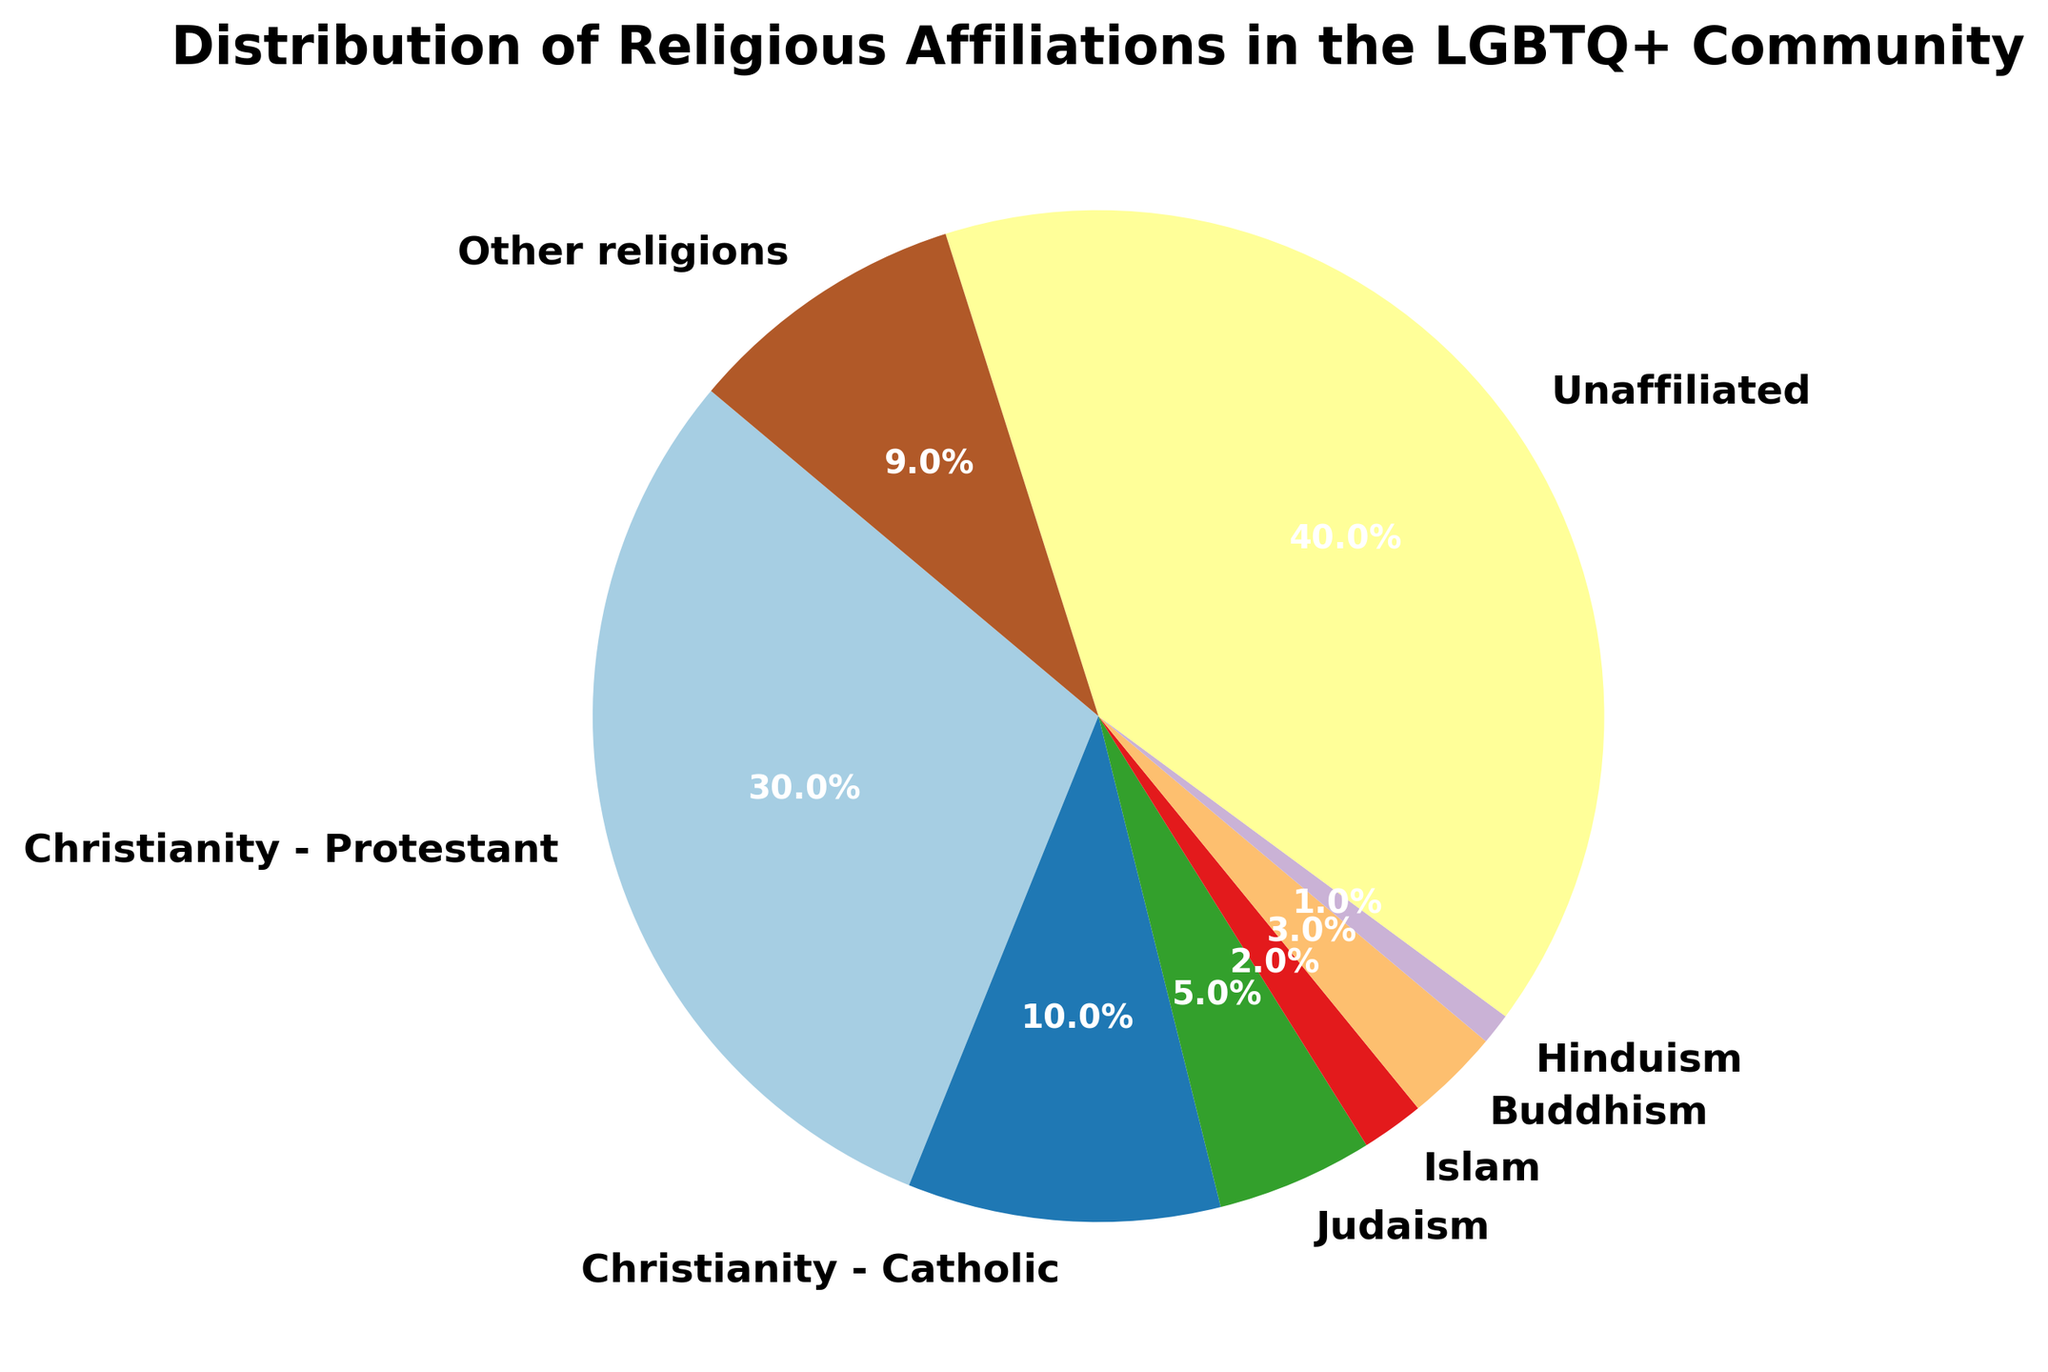What's the most represented religious affiliation in the LGBTQ+ community according to the figure? The pie chart shows different religious affiliations and their percentages. The largest segment is the "Unaffiliated" category.
Answer: Unaffiliated What is the combined percentage of individuals identifying with Christianity (both Protestant and Catholic) in the LGBTQ+ community? Sum the percentages of "Christianity - Protestant" and "Christianity - Catholic": 30% + 10%.
Answer: 40% Which religious affiliation has a higher percentage, Judaism or Buddhism? Compare the percentages of Judaism (5%) and Buddhism (3%).
Answer: Judaism How many more percentage points of the LGBTQ+ community are unaffiliated compared to those identifying as Catholic? Subtract the percentage of "Christianity - Catholic" from "Unaffiliated": 40% - 10%.
Answer: 30% What fraction of the LGBTQ+ community identifies with religions other than Christianity, Judaism, Islam, Buddhism, or Hinduism? The "Other religions" category represents all those not separately listed. Look at its percentage, 9%.
Answer: 9% Which two religious affiliations have the smallest representation in the LGBTQ+ community? Identify the affiliations with the smallest percentages, which are "Hinduism" at 1% and "Islam" at 2%.
Answer: Islam/Hinduism How many times larger is the percentage of Protestants compared to the percentage of Muslims in the LGBTQ+ community? Divide the percentage of Protestants by the percentage of Muslims: 30% / 2% = 15.
Answer: 15 What is the average percentage of individuals identifying with Christianity (Protestant and Catholic), Judaism, Islam, Buddhism, and Hinduism? Sum these percentages and divide by the number of categories: (30% + 10% + 5% + 2% + 3% + 1%) / 6 = 51% / 6.
Answer: 8.5% What is the difference in percentage points between the largest and smallest represented religious affiliations? Subtract the smallest percentage (Hinduism, 1%) from the largest percentage (Unaffiliated, 40%).
Answer: 39% 